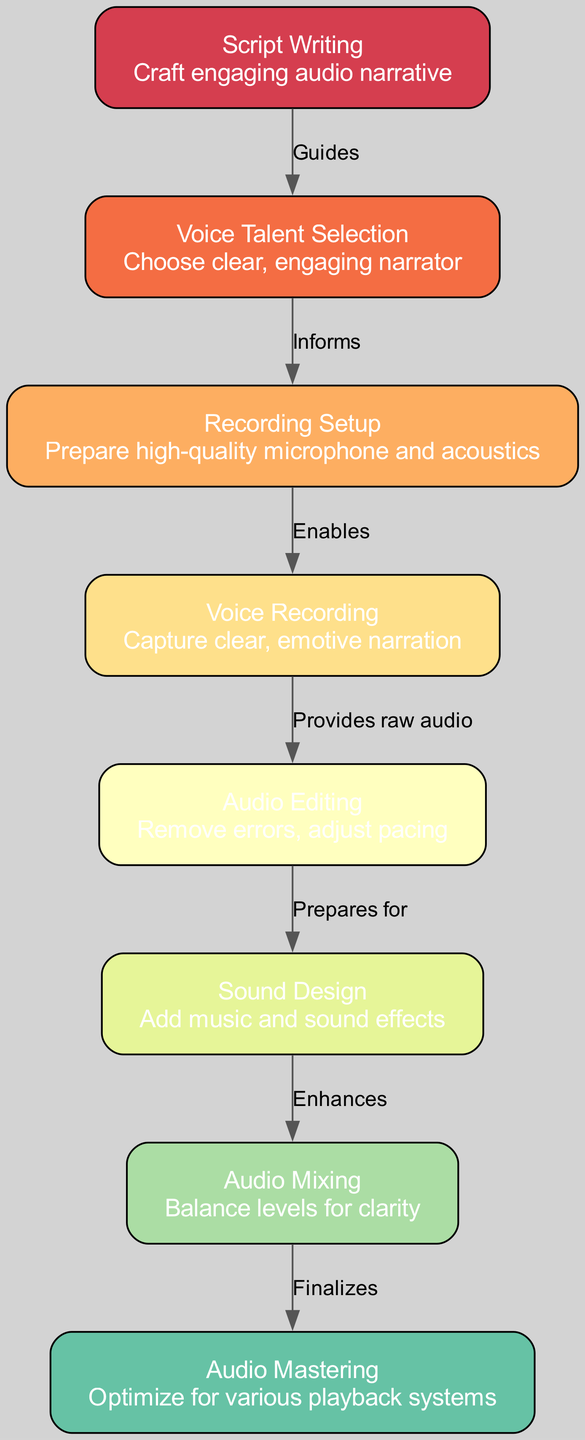What is the first step in the audio production process? The diagram shows that the first step is "Script Writing," which is labeled as the starting point of the flowchart.
Answer: Script Writing How many nodes are there in the diagram? By counting each unique step in the flowchart, we find there are a total of 8 nodes representing different stages in audio production.
Answer: 8 What does "Voice Talent Selection" inform? The edge from "Voice Talent Selection" to "Recording Setup" is labeled "Informs," indicating that it provides important information for the next step.
Answer: Recording Setup Which step comes after "Audio Editing"? Following the flow of the edges, "Audio Editing" leads to "Sound Design," making it the step that comes next in the process.
Answer: Sound Design What is added during the "Sound Design" phase? The description for "Sound Design" specifically mentions the addition of music and sound effects as part of this stage in audio production.
Answer: Music and sound effects Which process finalizes the audio? The diagram indicates that "Audio Mastering" is the final step in the audio production process and is the stage that completes the audio work.
Answer: Audio Mastering How many edges are there in total in this flowchart? By analyzing the connections between the nodes, we can see there are 7 edges, indicating the relationships between the various stages of audio production.
Answer: 7 Which node provides raw audio? The edge from "Voice Recording" to "Audio Editing" is labeled "Provides raw audio," indicating that "Voice Recording" is the source of the audio for the editing phase.
Answer: Voice Recording What is the relationship between "Audio Mixing" and "Audio Mastering"? The edge connecting "Audio Mixing" to "Audio Mastering" is labeled "Finalizes," which signifies that mixing the audio levels precedes and prepares it for mastering.
Answer: Finalizes 